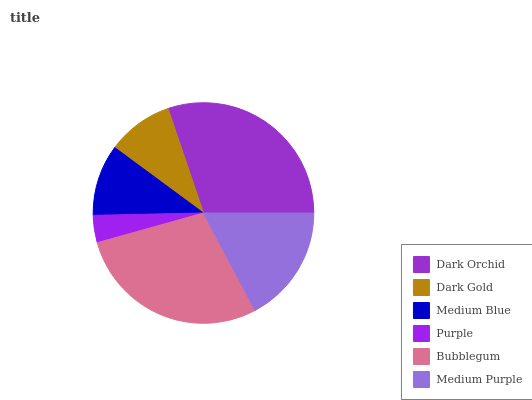Is Purple the minimum?
Answer yes or no. Yes. Is Dark Orchid the maximum?
Answer yes or no. Yes. Is Dark Gold the minimum?
Answer yes or no. No. Is Dark Gold the maximum?
Answer yes or no. No. Is Dark Orchid greater than Dark Gold?
Answer yes or no. Yes. Is Dark Gold less than Dark Orchid?
Answer yes or no. Yes. Is Dark Gold greater than Dark Orchid?
Answer yes or no. No. Is Dark Orchid less than Dark Gold?
Answer yes or no. No. Is Medium Purple the high median?
Answer yes or no. Yes. Is Medium Blue the low median?
Answer yes or no. Yes. Is Medium Blue the high median?
Answer yes or no. No. Is Dark Gold the low median?
Answer yes or no. No. 